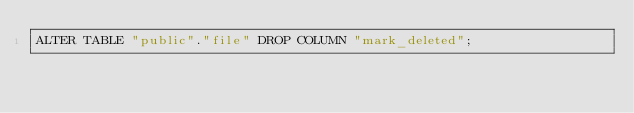Convert code to text. <code><loc_0><loc_0><loc_500><loc_500><_SQL_>ALTER TABLE "public"."file" DROP COLUMN "mark_deleted";
</code> 